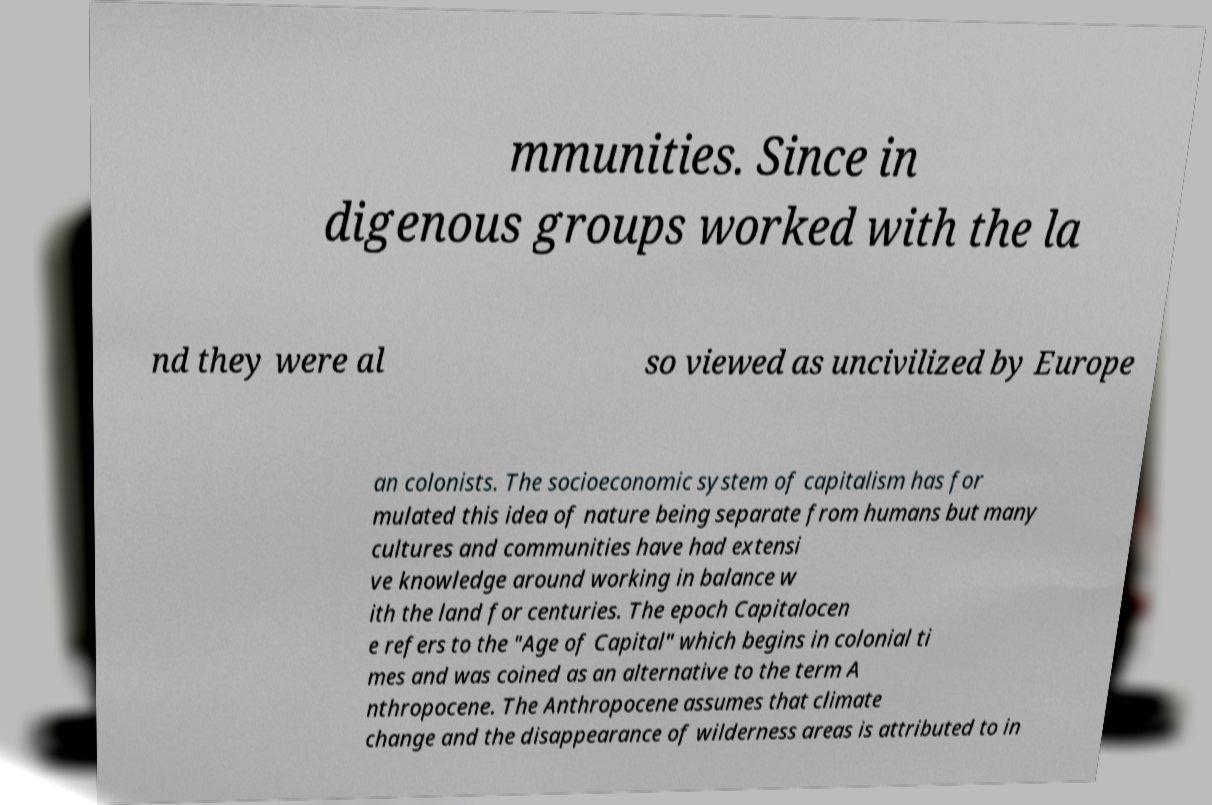I need the written content from this picture converted into text. Can you do that? mmunities. Since in digenous groups worked with the la nd they were al so viewed as uncivilized by Europe an colonists. The socioeconomic system of capitalism has for mulated this idea of nature being separate from humans but many cultures and communities have had extensi ve knowledge around working in balance w ith the land for centuries. The epoch Capitalocen e refers to the "Age of Capital" which begins in colonial ti mes and was coined as an alternative to the term A nthropocene. The Anthropocene assumes that climate change and the disappearance of wilderness areas is attributed to in 